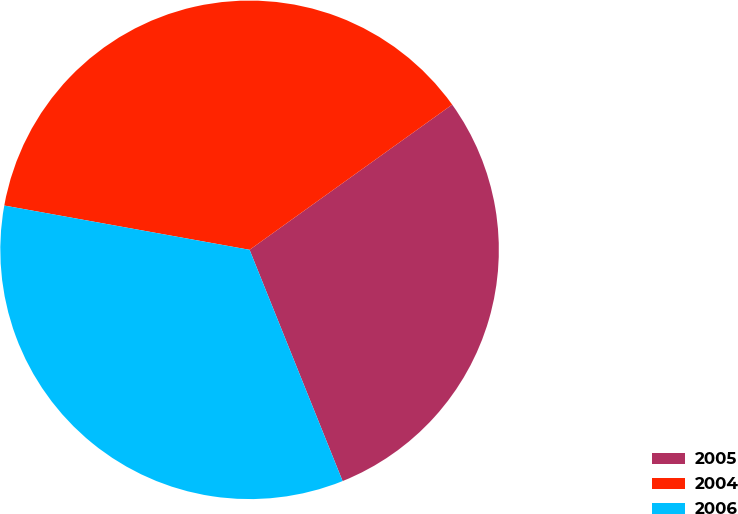Convert chart. <chart><loc_0><loc_0><loc_500><loc_500><pie_chart><fcel>2005<fcel>2004<fcel>2006<nl><fcel>28.81%<fcel>37.26%<fcel>33.93%<nl></chart> 